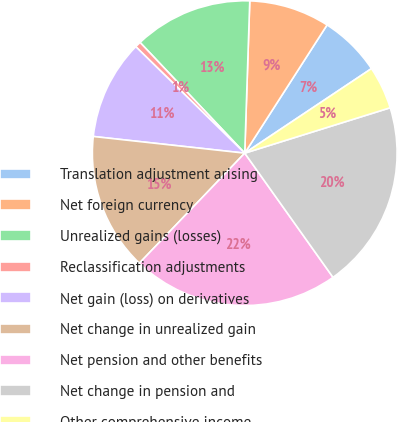Convert chart to OTSL. <chart><loc_0><loc_0><loc_500><loc_500><pie_chart><fcel>Translation adjustment arising<fcel>Net foreign currency<fcel>Unrealized gains (losses)<fcel>Reclassification adjustments<fcel>Net gain (loss) on derivatives<fcel>Net change in unrealized gain<fcel>Net pension and other benefits<fcel>Net change in pension and<fcel>Other comprehensive income<nl><fcel>6.55%<fcel>8.56%<fcel>12.58%<fcel>0.63%<fcel>10.57%<fcel>14.59%<fcel>21.99%<fcel>19.98%<fcel>4.55%<nl></chart> 